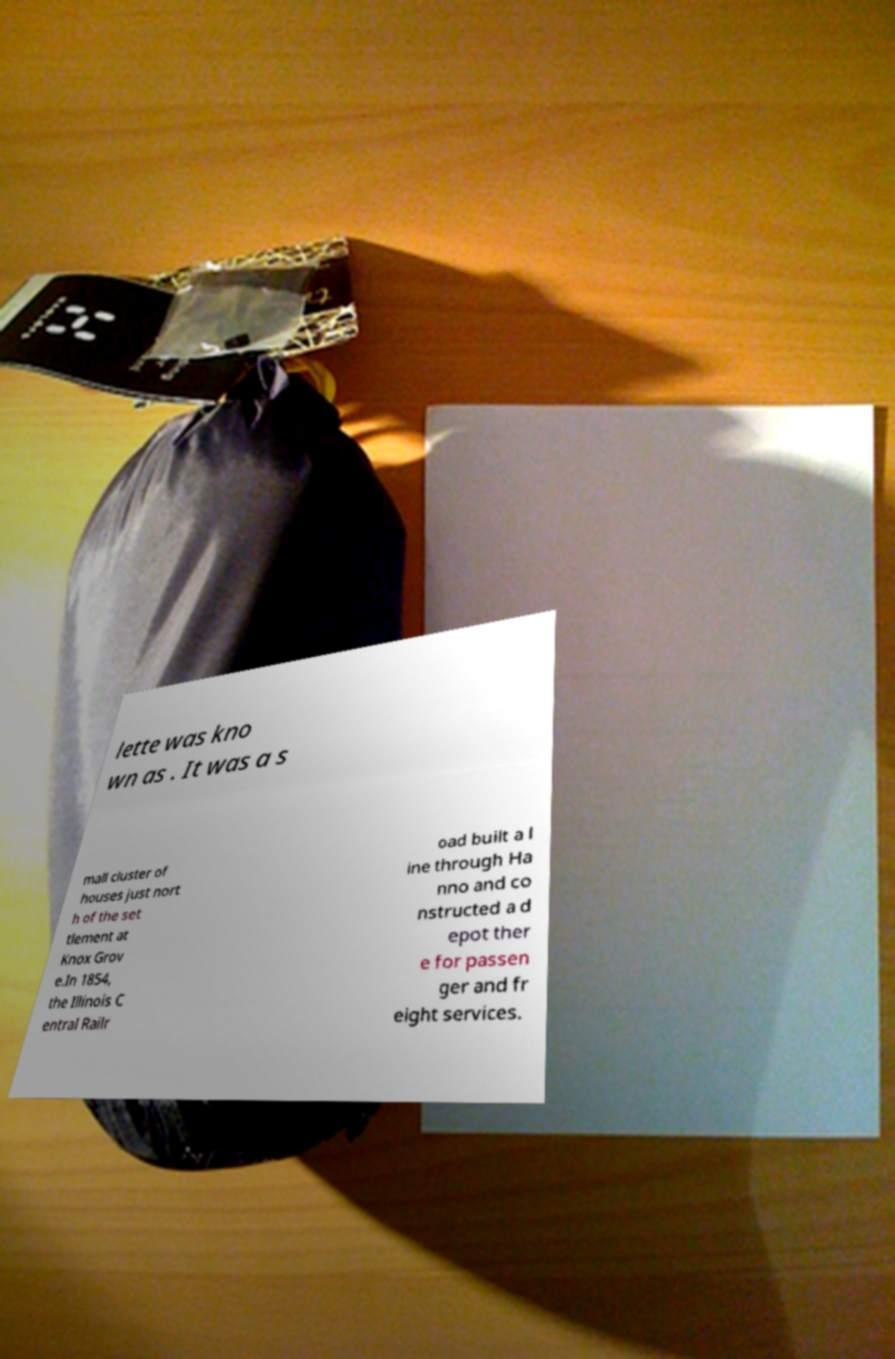Can you accurately transcribe the text from the provided image for me? lette was kno wn as . It was a s mall cluster of houses just nort h of the set tlement at Knox Grov e.In 1854, the Illinois C entral Railr oad built a l ine through Ha nno and co nstructed a d epot ther e for passen ger and fr eight services. 